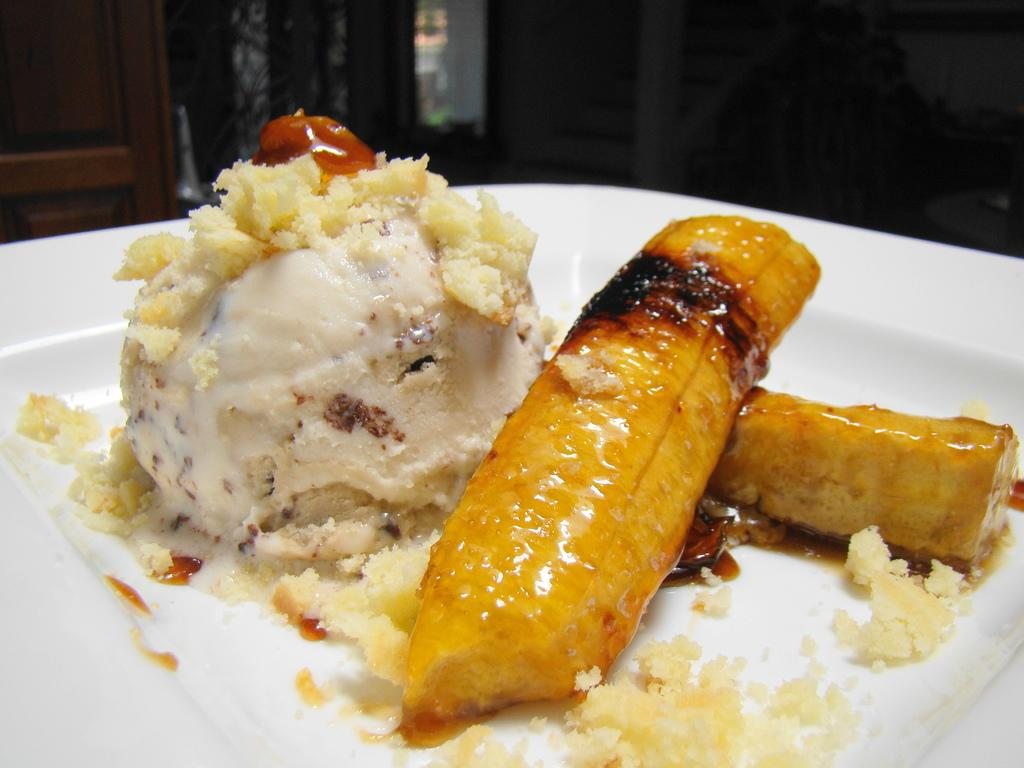What is on the plate in the image? There are food items on a plate in the image. What can be seen in the background of the image? There is a background with objects in the image. What material is visible in the image? Wood is visible in the image. How does the love between the two people in the image manifest itself? There are no people present in the image, and therefore no love can be observed. 